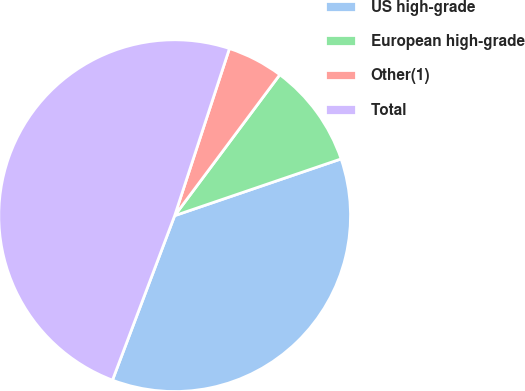<chart> <loc_0><loc_0><loc_500><loc_500><pie_chart><fcel>US high-grade<fcel>European high-grade<fcel>Other(1)<fcel>Total<nl><fcel>35.98%<fcel>9.57%<fcel>5.16%<fcel>49.29%<nl></chart> 